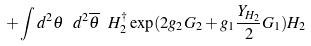Convert formula to latex. <formula><loc_0><loc_0><loc_500><loc_500>+ \int { d ^ { 2 } \theta \ d ^ { 2 } \overline { \theta } } \ H ^ { \dagger } _ { 2 } \exp ( 2 g _ { 2 } G _ { 2 } + g _ { 1 } \frac { Y _ { H _ { 2 } } } { 2 } G _ { 1 } ) H _ { 2 }</formula> 